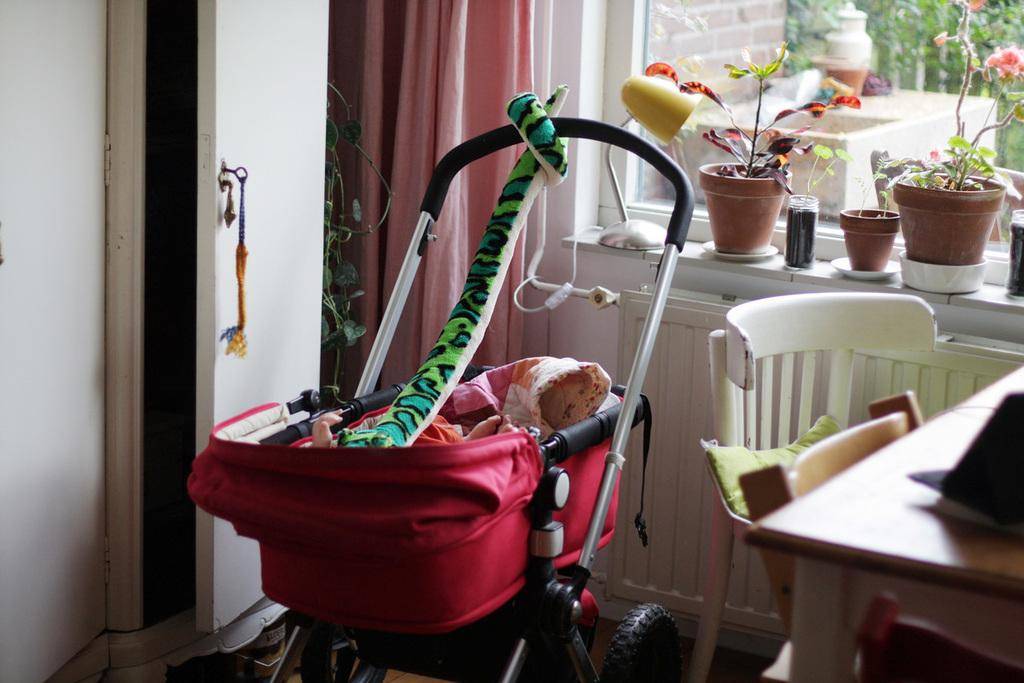What type of furniture is present in the image? There is a table, a chair, and a cupboard in the image. What is the purpose of the children's trolley in the image? The children's trolley is likely used for carrying toys or other items. What can be seen at the back side of the image? There is a flower pot, a curtain, and a cupboard at the back side of the image. How many pigs are visible in the image? There are no pigs present in the image. What type of rock is used as a decorative element in the image? There is no rock present in the image. 